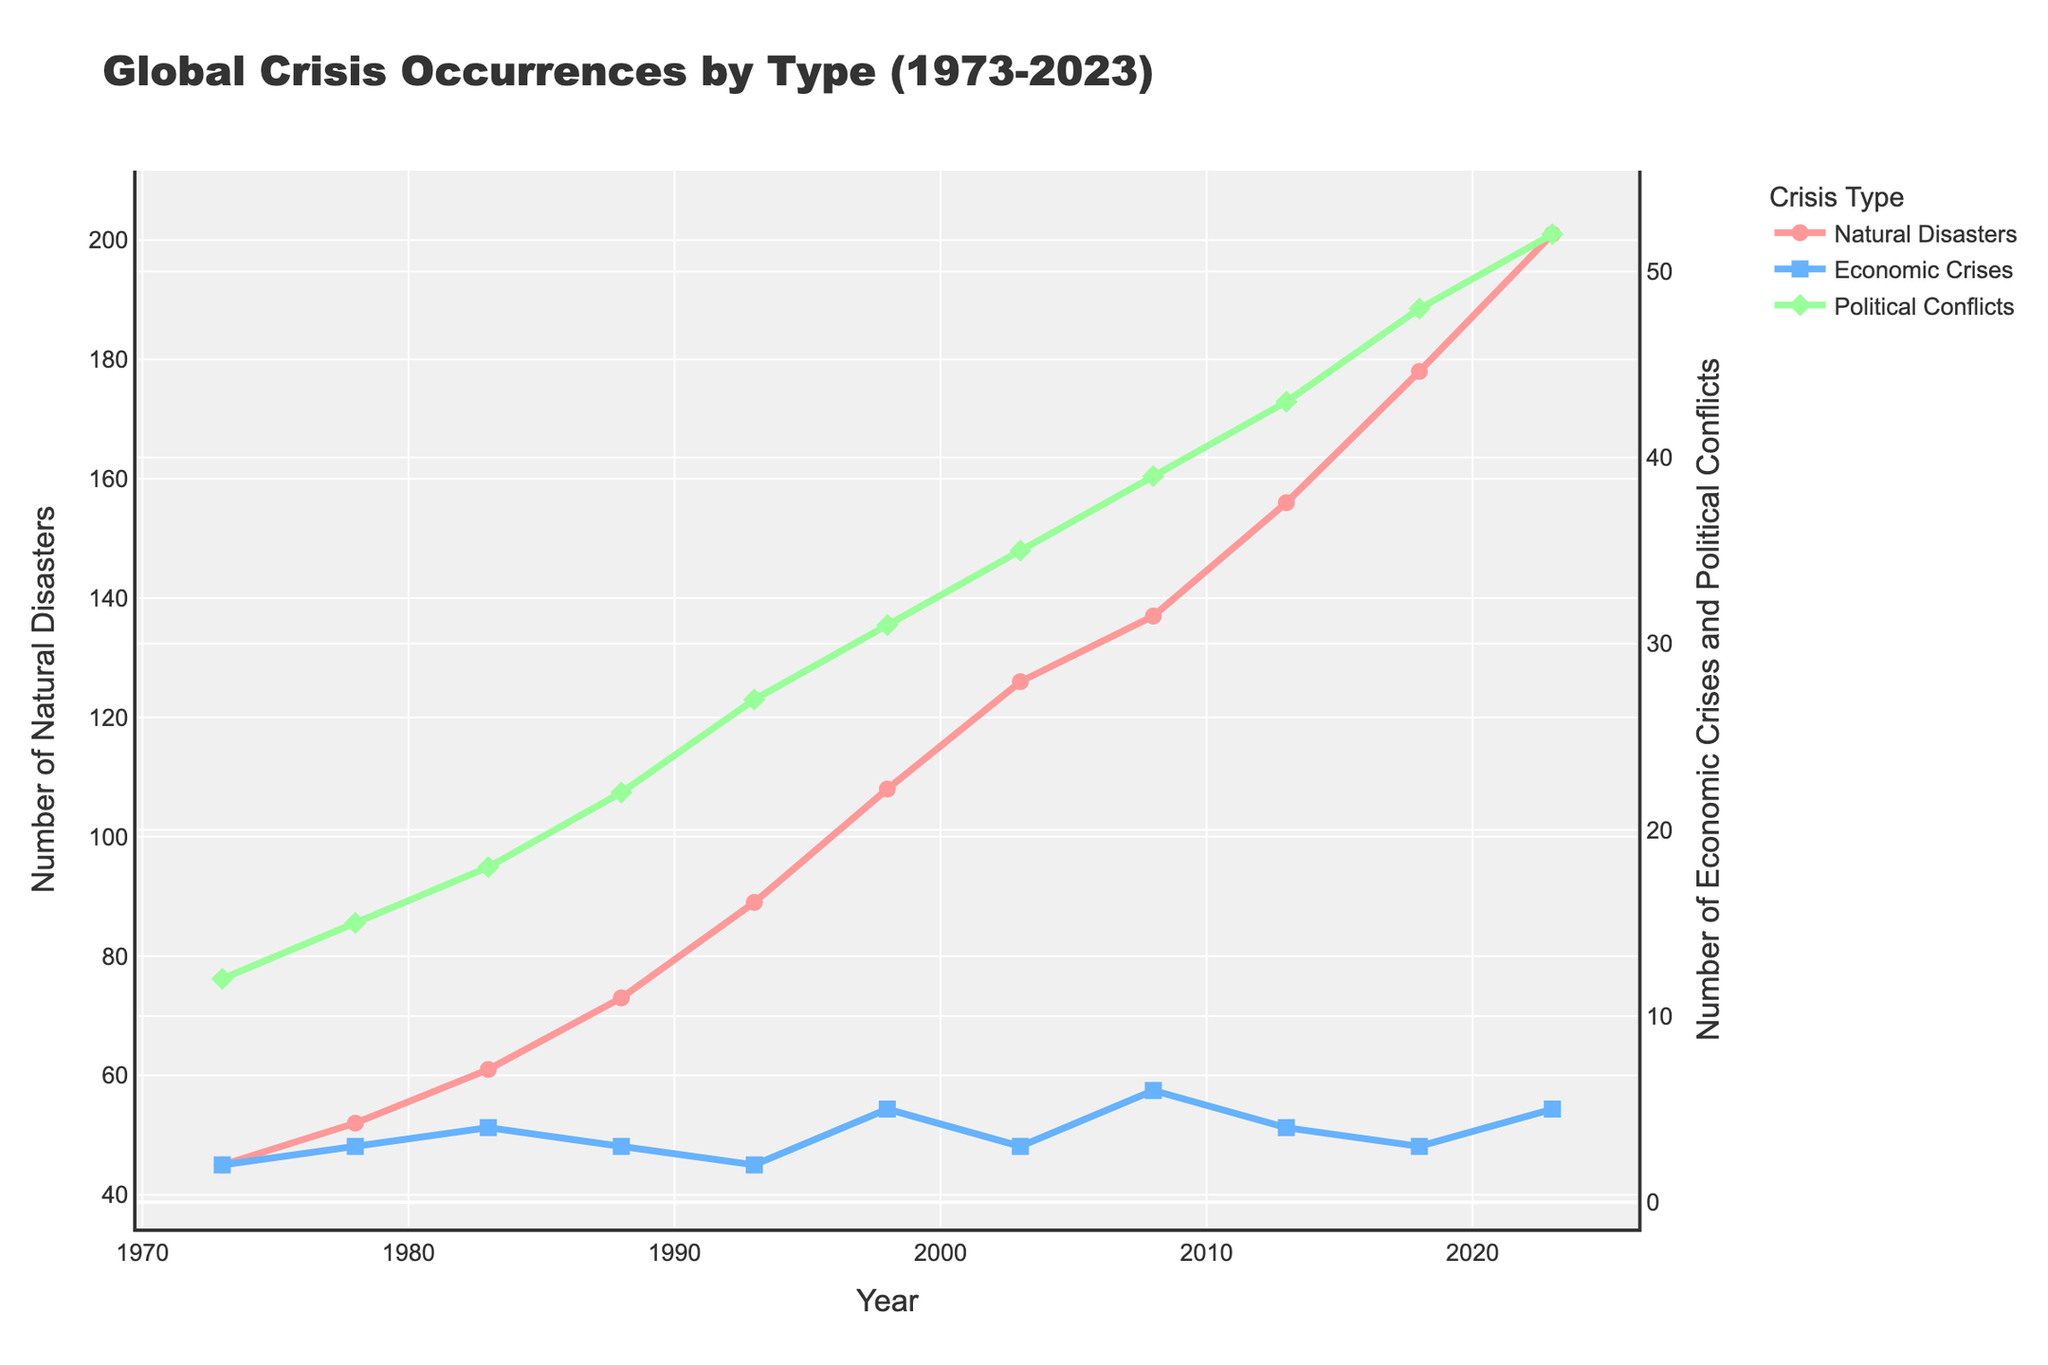Which type of crisis saw the largest increase in occurrences from 1973 to 2023? Natural disasters increased from 45 in 1973 to 201 in 2023. Economic crises increased from 2 to 5, and political conflicts increased from 12 to 52. The largest increase is seen in natural disasters (201 - 45 = 156).
Answer: Natural disasters How many total occurrences of natural disasters were recorded in 1983? The figure shows that in 1983, there were 61 natural disasters.
Answer: 61 Which type of crisis had the highest number of occurrences in 2018? In 2018, the figure shows 178 natural disasters, 3 economic crises, and 48 political conflicts. The highest number is natural disasters.
Answer: Natural disasters Compare the trends of economic crises and political conflicts between 2003 to 2023. Which experienced more fluctuations? From 2003 to 2023, economic crises data fluctuates around 3 to 6 occurrences. Political conflicts consistently increased from 35 to 52 showing a more steady trend. Economic crises experienced more fluctuations.
Answer: Economic crises In what year did natural disasters surpass 100 occurrences for the first time? The figure shows that the natural disasters surpassed 100 occurrences in 1998.
Answer: 1998 What is the overall trend for political conflicts from 1973 to 2023? The number of political conflicts increases steadily from 12 in 1973 to 52 in 2023.
Answer: Steady increase Calculate the average number of natural disasters from 1973 to 1998. The numbers are 45, 52, 61, 73, 89, and 108 over the given years. The sum is 428, and there are 6 data points. The average is 428 / 6 = 71.33.
Answer: 71.33 Which type of crisis had the least occurrences in 1988? In 1988, there were 73 natural disasters, 3 economic crises, and 22 political conflicts. Economic crises had the least number of occurrences.
Answer: Economic crises Compare the number of occurrences of economic crises and natural disasters in 2008. In 2008, economic crises were 6, and natural disasters were 137. Comparing these, economic crises are fewer.
Answer: Economic crises How many total occurrences of all crisis types were recorded in 1983? The figure shows 61 natural disasters, 4 economic crises, and 18 political conflicts in 1983. Sum these: 61 + 4 + 18 = 83.
Answer: 83 